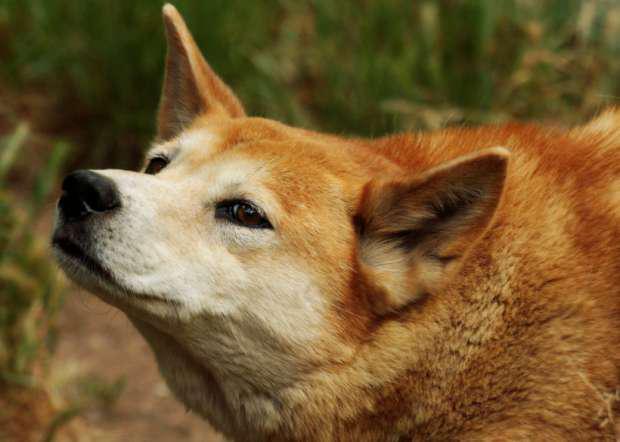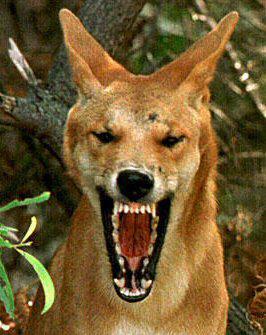The first image is the image on the left, the second image is the image on the right. Analyze the images presented: Is the assertion "At least one image features multiple dogs." valid? Answer yes or no. No. 